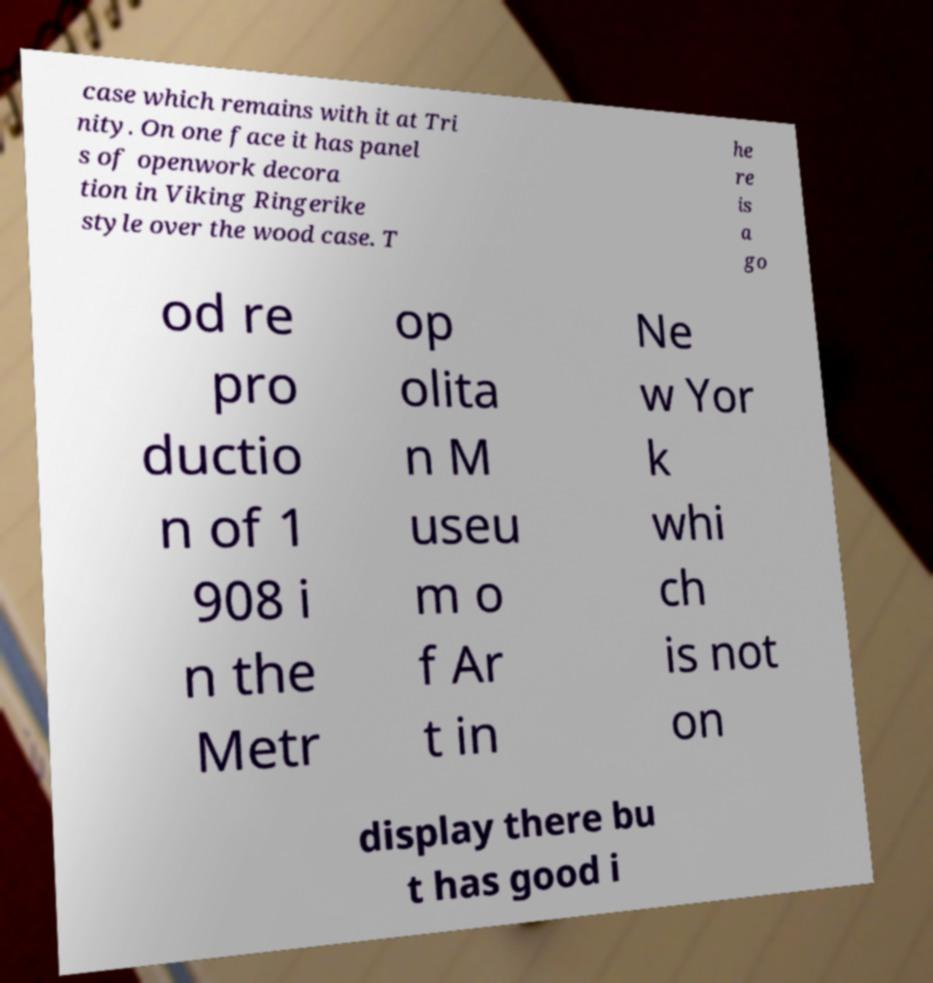Please identify and transcribe the text found in this image. case which remains with it at Tri nity. On one face it has panel s of openwork decora tion in Viking Ringerike style over the wood case. T he re is a go od re pro ductio n of 1 908 i n the Metr op olita n M useu m o f Ar t in Ne w Yor k whi ch is not on display there bu t has good i 